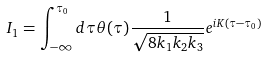Convert formula to latex. <formula><loc_0><loc_0><loc_500><loc_500>I _ { 1 } = \int _ { - \infty } ^ { \tau _ { 0 } } d \tau \theta ( \tau ) \frac { 1 } { \sqrt { 8 k _ { 1 } k _ { 2 } k _ { 3 } } } e ^ { i K ( \tau - \tau _ { 0 } ) }</formula> 